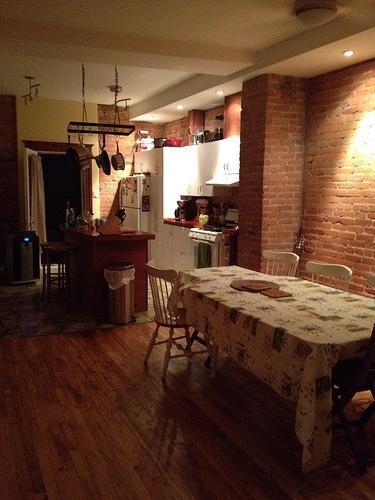How many chairs are there?
Give a very brief answer. 4. 